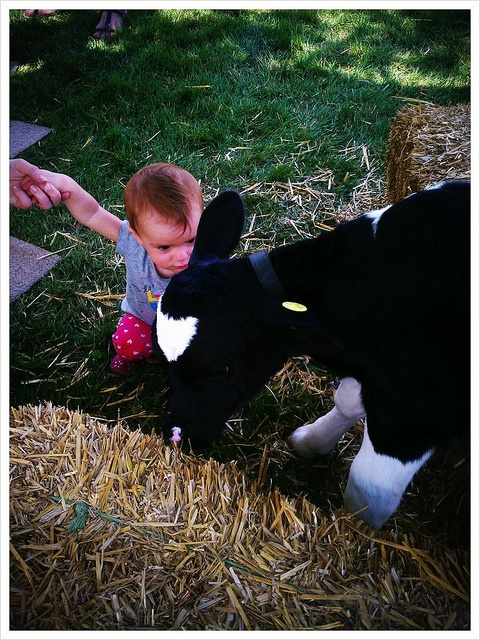Describe the objects in this image and their specific colors. I can see cow in lightgray, black, darkgray, white, and gray tones, people in lightgray, maroon, brown, black, and gray tones, and people in lightgray, brown, violet, maroon, and purple tones in this image. 